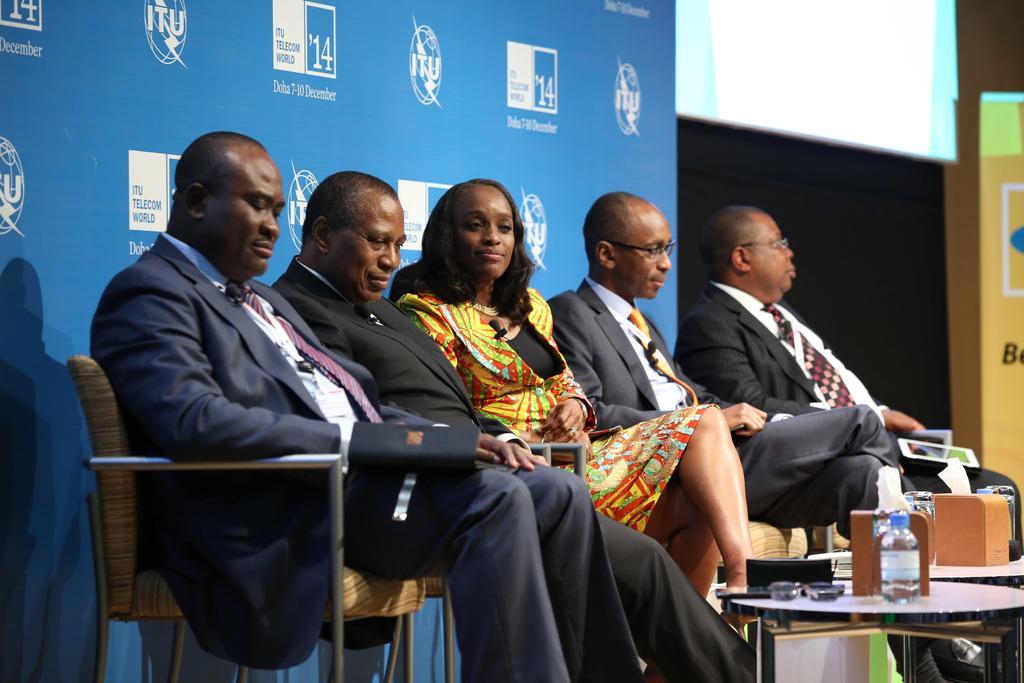In one or two sentences, can you explain what this image depicts? This picture shows group of people seated on the chairs and we see a water bottle on the table and we see a hoarding back of them 